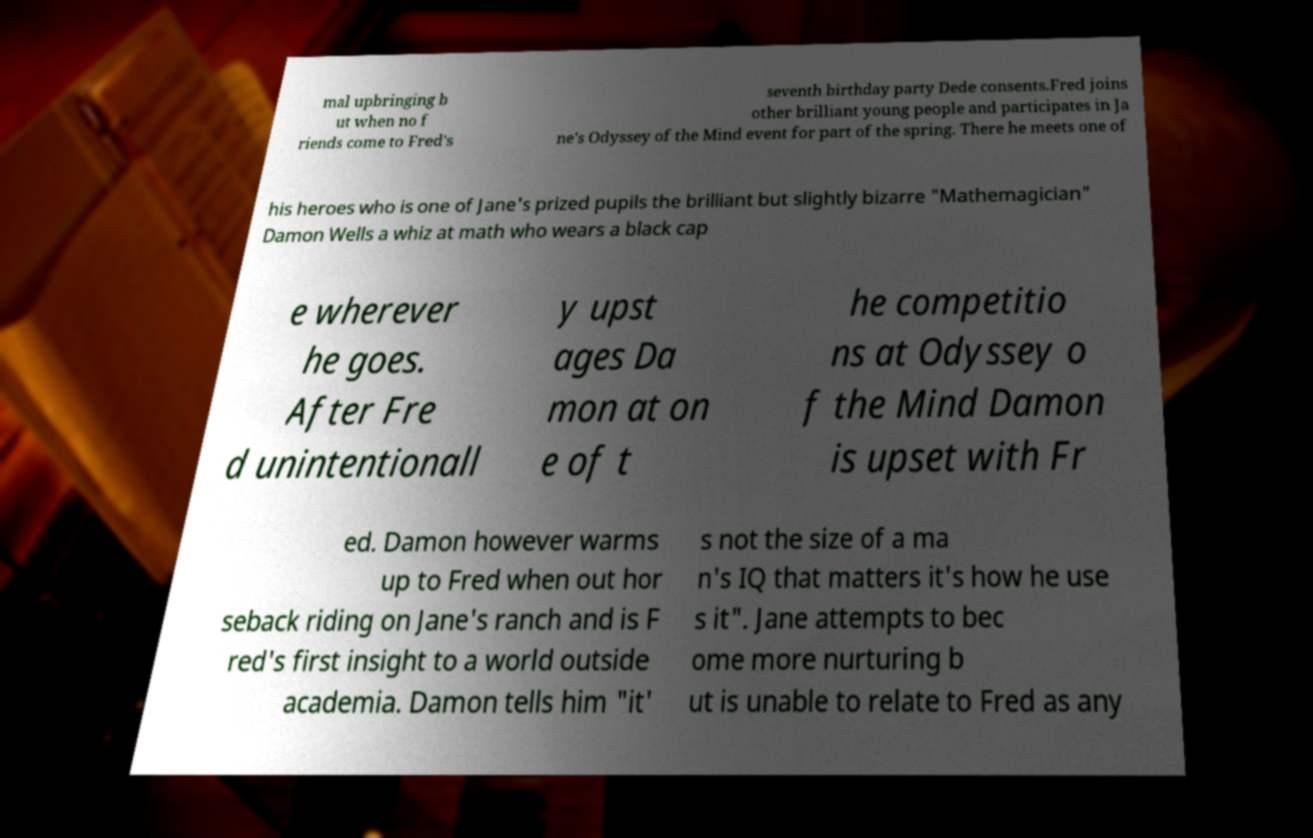Please read and relay the text visible in this image. What does it say? mal upbringing b ut when no f riends come to Fred's seventh birthday party Dede consents.Fred joins other brilliant young people and participates in Ja ne's Odyssey of the Mind event for part of the spring. There he meets one of his heroes who is one of Jane's prized pupils the brilliant but slightly bizarre "Mathemagician" Damon Wells a whiz at math who wears a black cap e wherever he goes. After Fre d unintentionall y upst ages Da mon at on e of t he competitio ns at Odyssey o f the Mind Damon is upset with Fr ed. Damon however warms up to Fred when out hor seback riding on Jane's ranch and is F red's first insight to a world outside academia. Damon tells him "it' s not the size of a ma n's IQ that matters it's how he use s it". Jane attempts to bec ome more nurturing b ut is unable to relate to Fred as any 